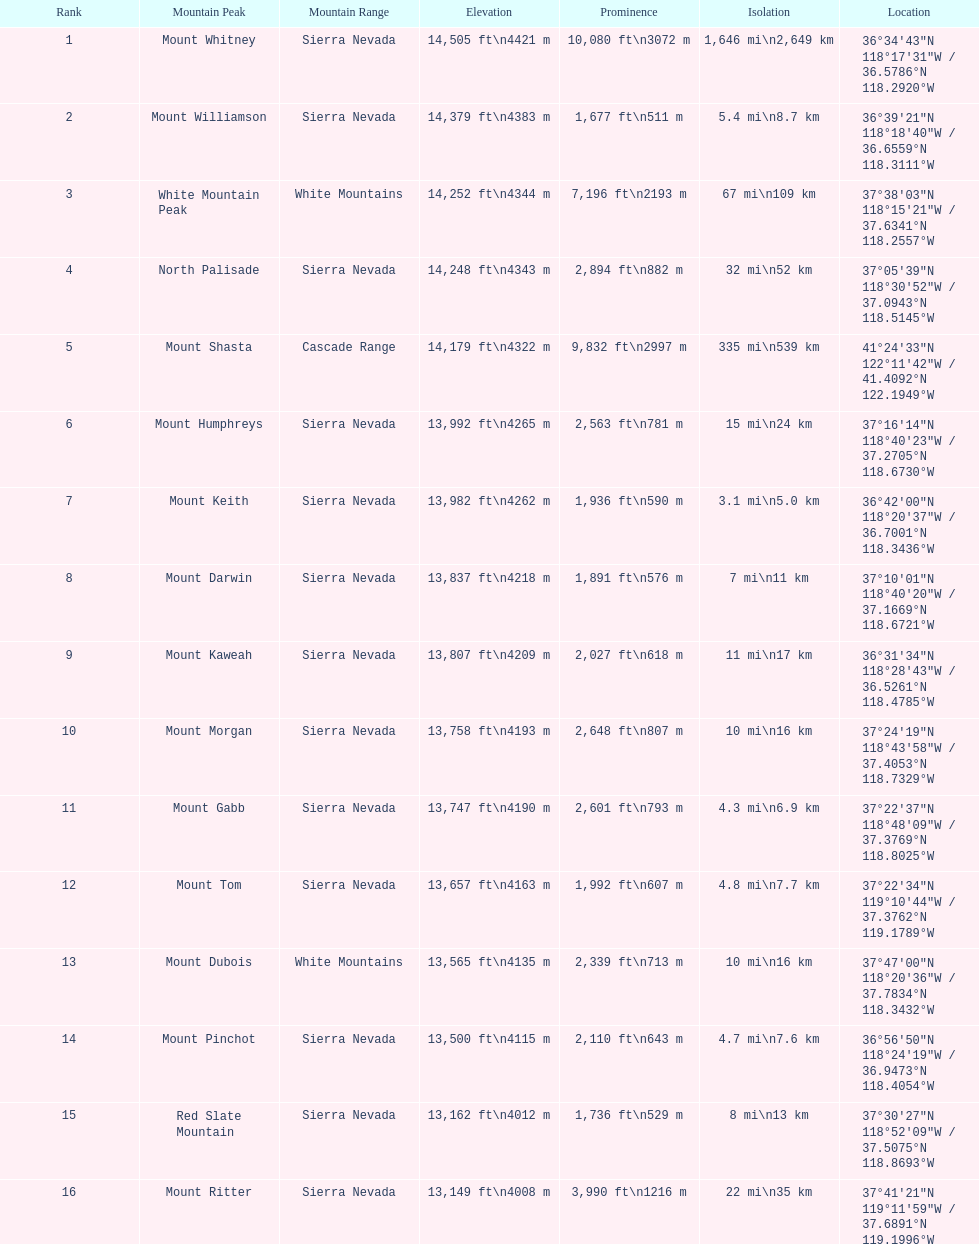In feet, what is the difference between the tallest peak and the 9th tallest peak in california? 698 ft. 